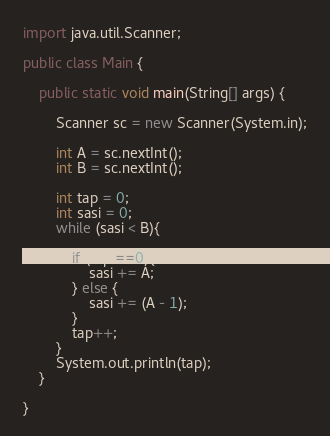<code> <loc_0><loc_0><loc_500><loc_500><_Java_>import java.util.Scanner;

public class Main {

	public static void main(String[] args) {

		Scanner sc = new Scanner(System.in);

		int A = sc.nextInt();
		int B = sc.nextInt();

		int tap = 0;
		int sasi = 0;
		while (sasi < B){

			if (tap ==0){
				sasi += A;
			} else {
				sasi += (A - 1);
			}
			tap++;
		}
		System.out.println(tap);
	}

}</code> 